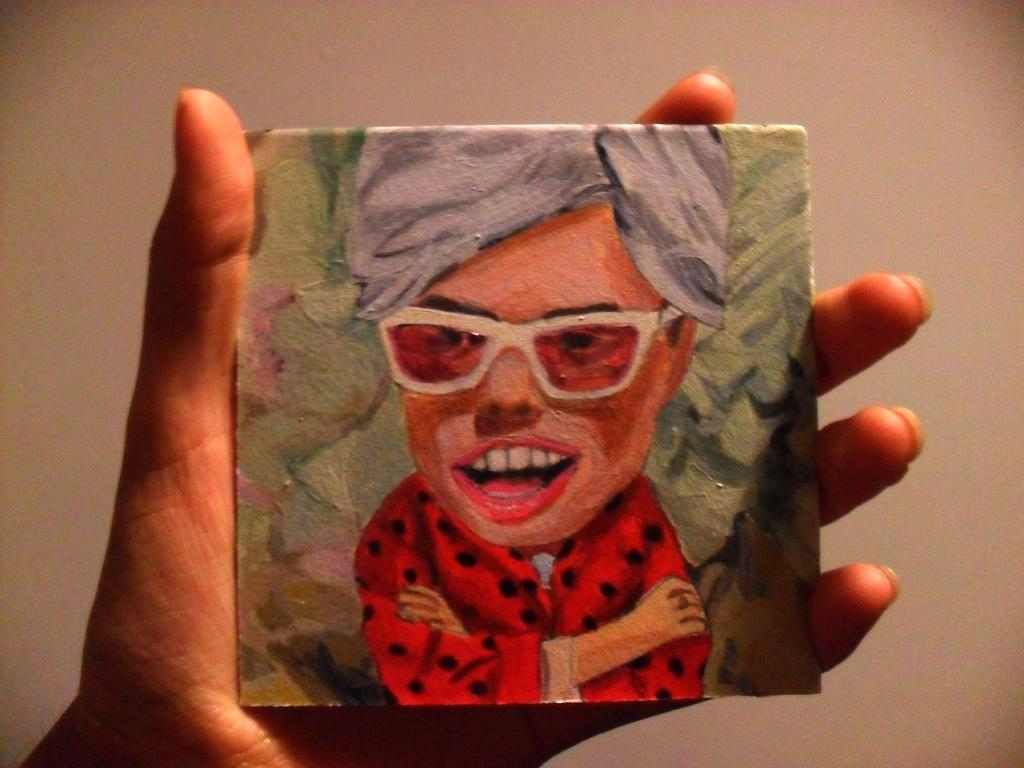What part of a person's body is visible in the image? There is a person's hand in the image. What is the hand holding? The hand is holding an object with a painting of a person. What type of peace symbol can be seen on the person's hand in the image? There is no peace symbol present on the person's hand in the image. 